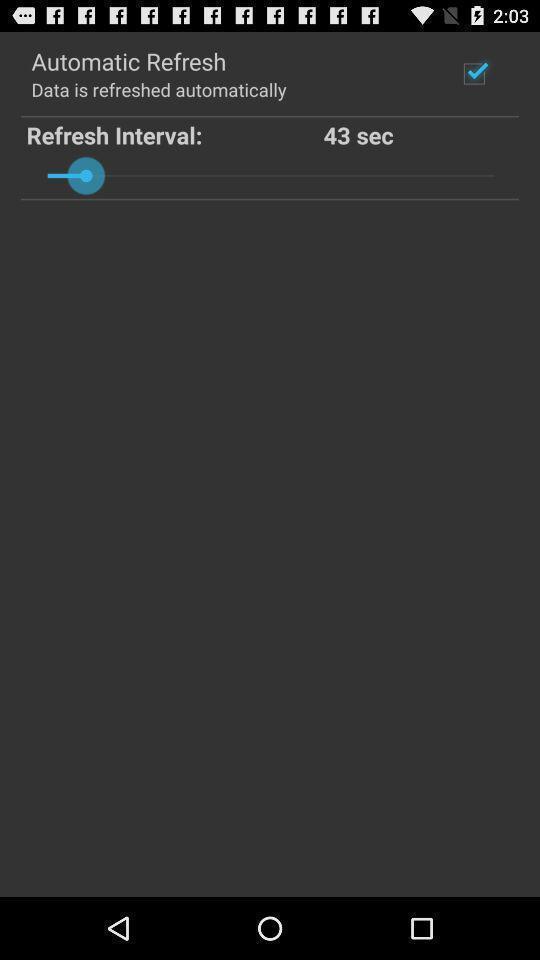Tell me what you see in this picture. Screen shows options. 